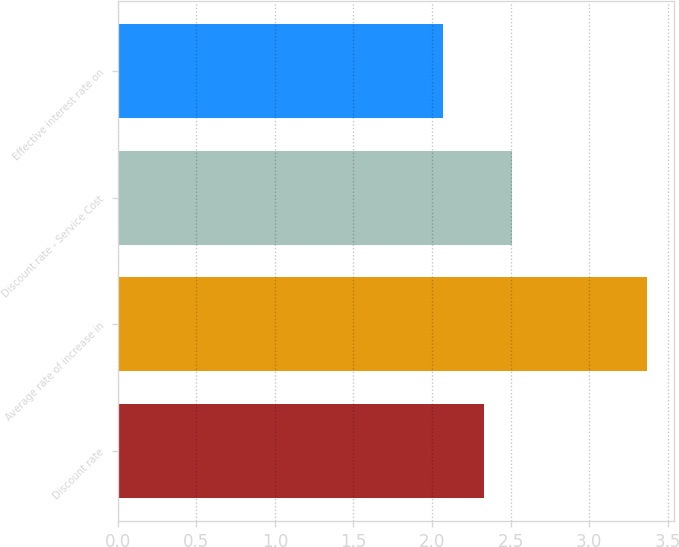Convert chart to OTSL. <chart><loc_0><loc_0><loc_500><loc_500><bar_chart><fcel>Discount rate<fcel>Average rate of increase in<fcel>Discount rate - Service Cost<fcel>Effective interest rate on<nl><fcel>2.33<fcel>3.37<fcel>2.51<fcel>2.07<nl></chart> 